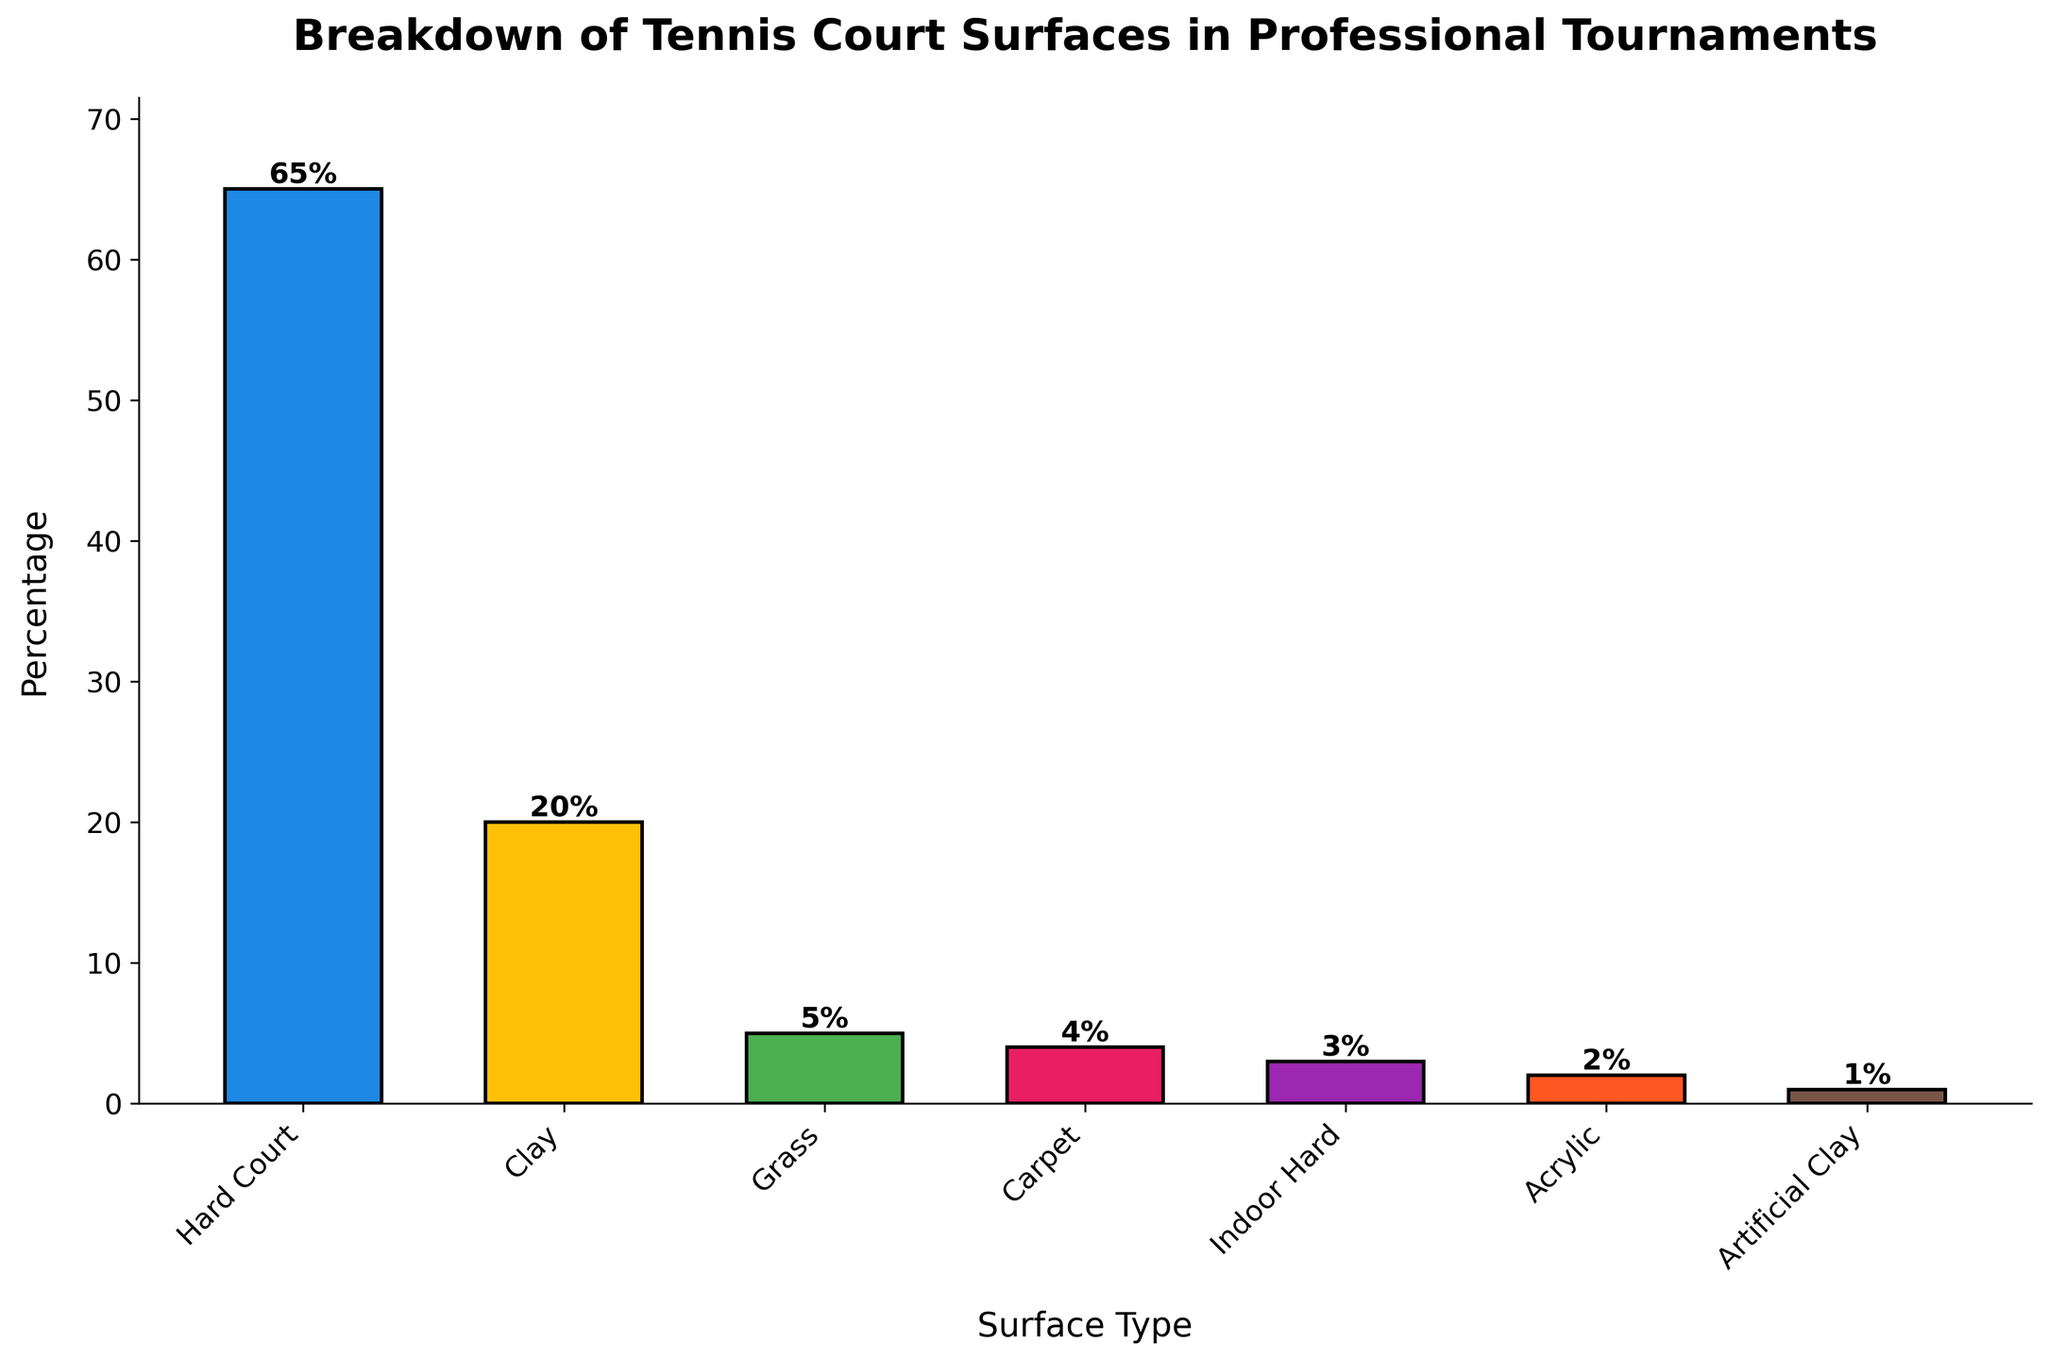What percentage of professional tennis tournaments are played on hard court surfaces? Look at the height of the bar representing "Hard Court" and read the percentage label above it.
Answer: 65% Which surface type has the lowest percentage of professional tournaments? Identify the bar with the shortest height, and read the surface type below it.
Answer: Artificial Clay How much greater is the percentage of tournaments played on clay compared to grass? Subtract the percentage of grass from the percentage of clay: 20% - 5% = 15%.
Answer: 15% What is the combined percentage of tournaments played on Grass, Carpet, Indoor Hard, and Acrylic surfaces? Add the percentages of these four surfaces: 5% + 4% + 3% + 2% = 14%.
Answer: 14% How does the percentage of tournaments played on acrylic compare to those played on carpet? Compare the heights and read the values: Acrylic (2%) is less than Carpet (4%).
Answer: Acrylic is less What is the sum of the percentages for Hard Court, Clay, and Grass surfaces? Add the percentages for these surfaces: 65% (Hard Court) + 20% (Clay) + 5% (Grass) = 90%.
Answer: 90% If you combine the percentages of Indoor Hard and Artificial Clay surfaces, does their total exceed the percentage of Carpet surfaces? Add Indoor Hard and Artificial Clay: 3% + 1% = 4%, which is equal to Carpet (4%).
Answer: No, it's equal Which two surfaces have a total percentage of professional tournaments equal to the percentage of Clay surfaces? Identify the percentages that sum to 20%: Acrylic (2%) + Indoor Hard (3%) + Carpet (4%) + Grass (5%) = 14%, then Carpet (4%) + Grass (5%) + Artificial Clay (1%) = 10%, etc. Hard Court (65%) and none of the remaining match, but Indoor Hard and Acrylic together are a closer smallest possible surface total compared to the Clay percentage.
Answer: None Rank the surfaces in descending order of their percentages of professional tournaments. Write the surfaces from highest to lowest percentage according to the bar heights and labels: Hard Court (65%), Clay (20%), Grass (5%), Carpet (4%), Indoor Hard (3%), Acrylic (2%), Artificial Clay (1%).
Answer: Hard Court, Clay, Grass, Carpet, Indoor Hard, Acrylic, Artificial Clay On what surface type are exactly 65% of professional tennis tournaments played? Look at the surface type corresponding to the bar labeled with 65%.
Answer: Hard Court 